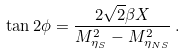Convert formula to latex. <formula><loc_0><loc_0><loc_500><loc_500>\tan 2 \phi = \frac { 2 \sqrt { 2 } \beta X } { M _ { \eta _ { S } } ^ { 2 } - M _ { \eta _ { N S } } ^ { 2 } } \, .</formula> 